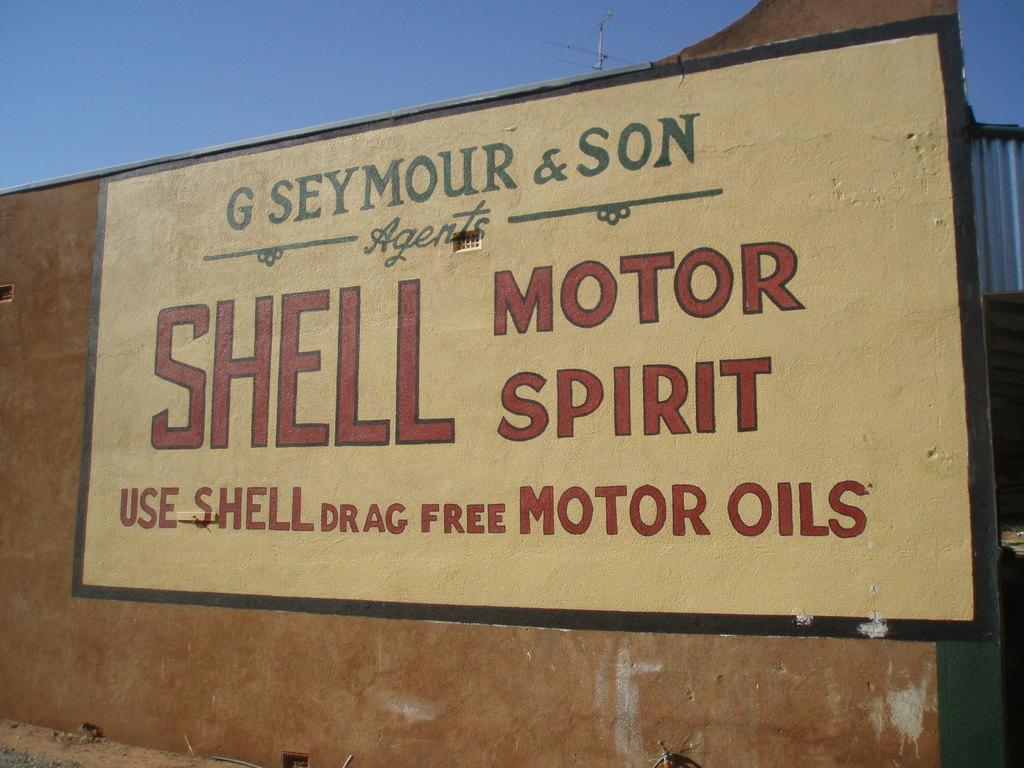Please provide a concise description of this image. In this image there is a wall. There is text painted on the wall. At the top there is the sky. Behind the wall there is an electric pole. 